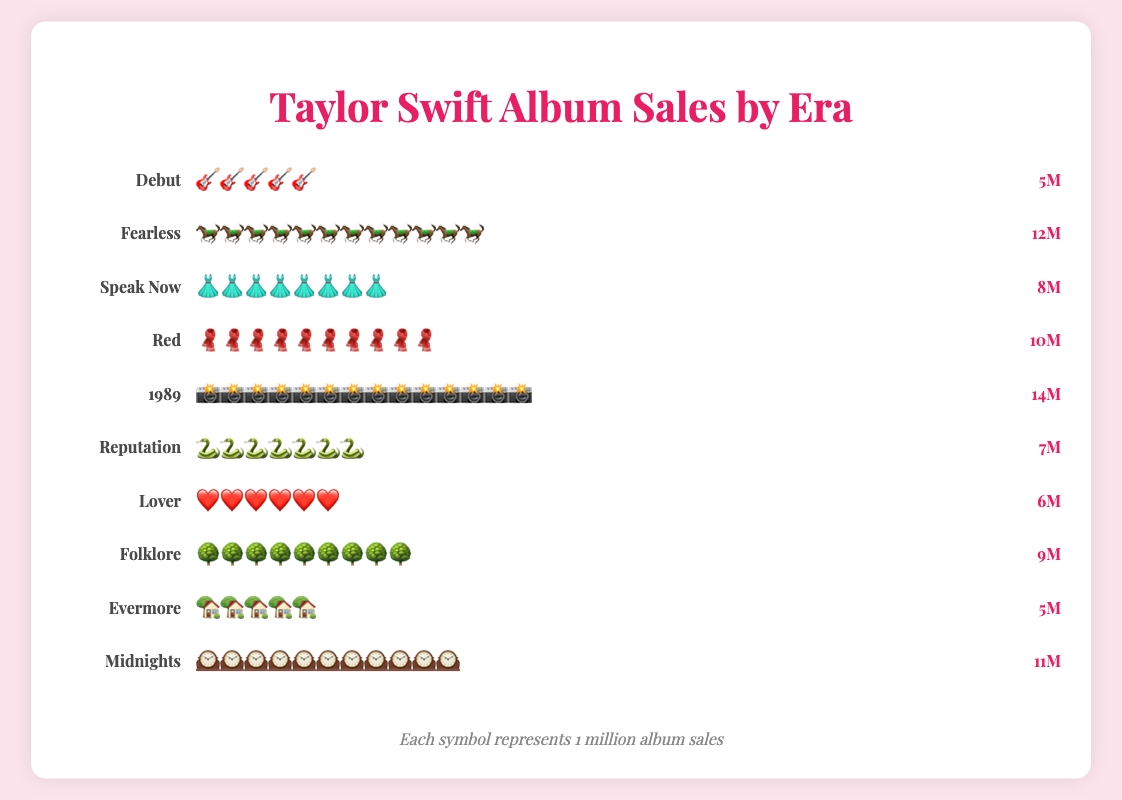Which Taylor Swift era has the highest album sales? By observing the number of symbols representing album sales for each era, "1989" has the most symbols (14) indicating the highest sales.
Answer: 1989 How many more albums did "Fearless" sell compared to "Debut"? "Fearless" sold 12 million albums, while "Debut" sold 5 million albums. The difference between them is 12 - 5 = 7 million albums.
Answer: 7 million Which era sold more albums, "Speak Now" or "Reputation"? By counting the symbols, "Speak Now" has 8 dresses and "Reputation" has 7 snakes, so "Speak Now" sold more albums.
Answer: Speak Now What is the total number of albums sold for "Red" and "Midnights" combined? "Red" sold 10 million albums and "Midnights" sold 11 million albums. The total number of albums sold combined is 10 + 11 = 21 million albums.
Answer: 21 million Is there any era that sold the same number of albums as another era? Both "Debut" and "Evermore" have 5 symbols each, indicating they sold the same number of albums.
Answer: Yes Which eras have album sales less than 10 million? The eras with sales less than 10 million are "Debut" (5), "Reputation" (7), "Lover" (6), "Evermore" (5).
Answer: Debut, Reputation, Lover, Evermore What is the average number of albums sold across all eras? First, sum all the album sales: 5 + 12 + 8 + 10 + 14 + 7 + 6 + 9 + 5 + 11 = 87 million albums. There are 10 eras, so the average is 87 / 10 = 8.7 million albums.
Answer: 8.7 million How many more albums did "1989" sell compared to the era with the least sales? "1989" sold 14 million albums, while both "Debut" and "Evermore" sold 5 million albums. The difference is 14 - 5 = 9 million albums.
Answer: 9 million What is the combined total of album sales for eras with symbol representing sales as a snake and a tree? "Reputation" has a snake symbol and sold 7 million albums, while "Folklore" has a tree symbol and sold 9 million albums. The combined total is 7 + 9 = 16 million albums.
Answer: 16 million What is the difference in album sales between the highest and lowest selling eras? The highest selling era "1989" sold 14 million albums, and the lowest selling eras "Debut" and "Evermore" sold 5 million albums each. The difference is 14 - 5 = 9 million albums.
Answer: 9 million 